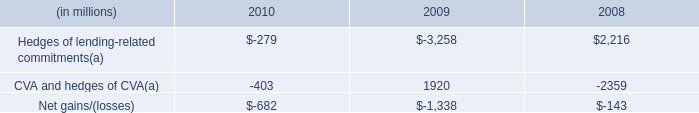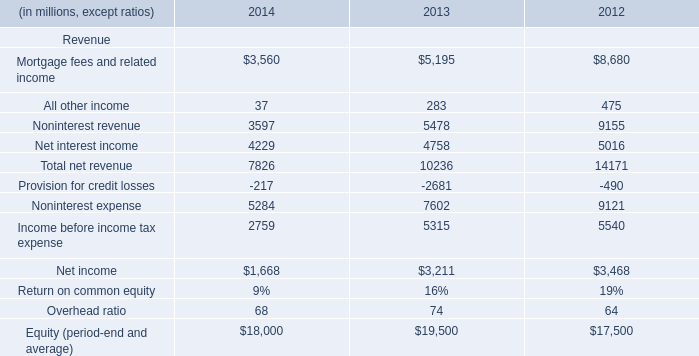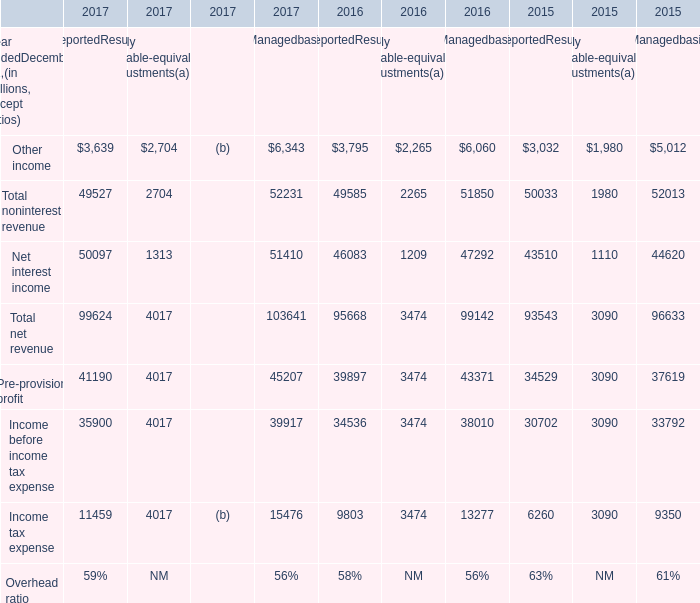Does the value of Other income in 2017 greater than that in 2016 for ReportedResults? 
Answer: no. 